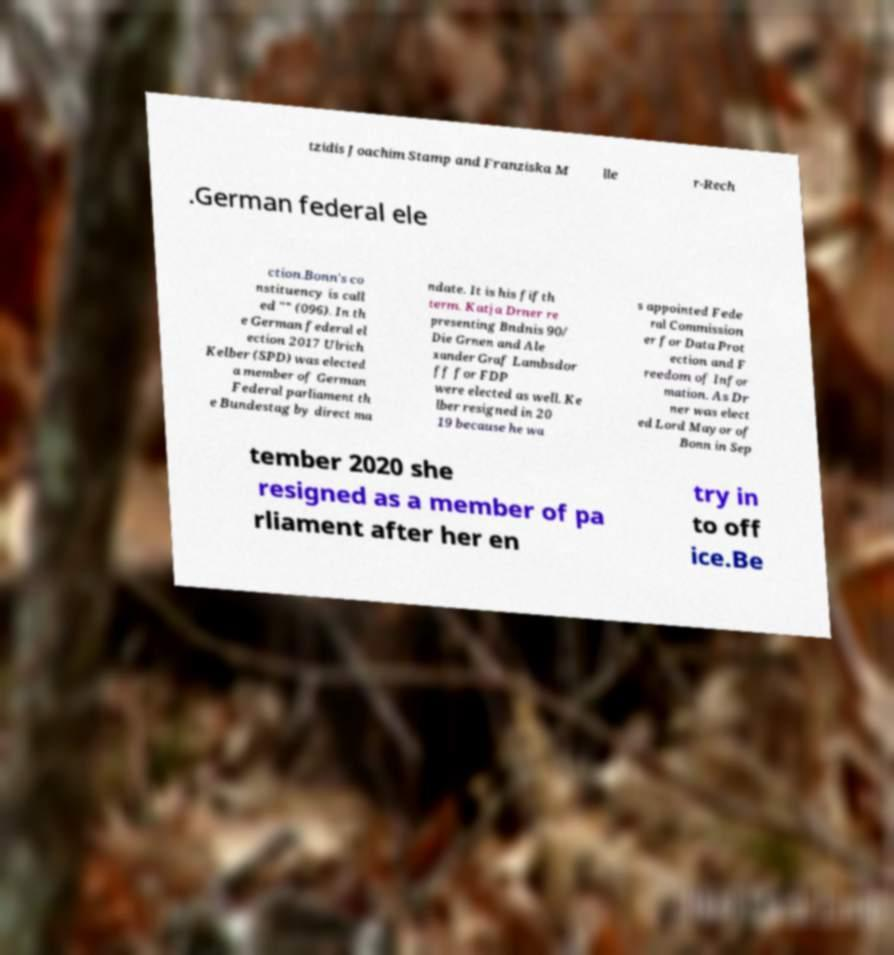Could you extract and type out the text from this image? tzidis Joachim Stamp and Franziska M lle r-Rech .German federal ele ction.Bonn's co nstituency is call ed "" (096). In th e German federal el ection 2017 Ulrich Kelber (SPD) was elected a member of German Federal parliament th e Bundestag by direct ma ndate. It is his fifth term. Katja Drner re presenting Bndnis 90/ Die Grnen and Ale xander Graf Lambsdor ff for FDP were elected as well. Ke lber resigned in 20 19 because he wa s appointed Fede ral Commission er for Data Prot ection and F reedom of Infor mation. As Dr ner was elect ed Lord Mayor of Bonn in Sep tember 2020 she resigned as a member of pa rliament after her en try in to off ice.Be 